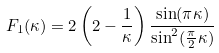Convert formula to latex. <formula><loc_0><loc_0><loc_500><loc_500>F _ { 1 } ( \kappa ) = 2 \left ( 2 - \frac { 1 } { \kappa } \right ) \frac { \sin ( \pi \kappa ) } { \sin ^ { 2 } ( \frac { \pi } { 2 } \kappa ) }</formula> 